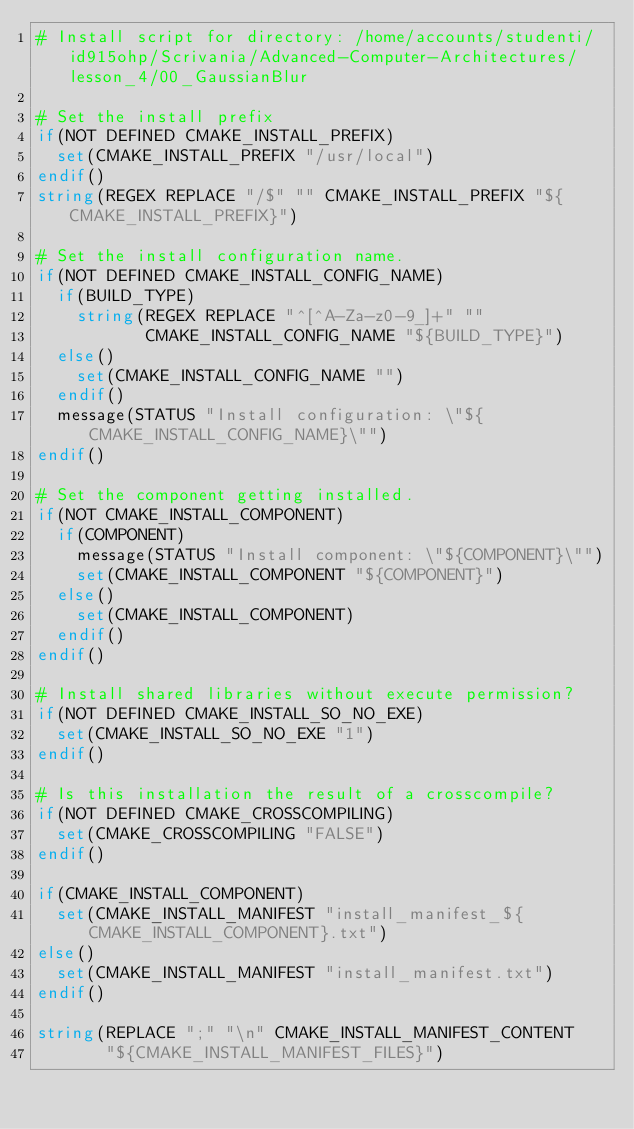Convert code to text. <code><loc_0><loc_0><loc_500><loc_500><_CMake_># Install script for directory: /home/accounts/studenti/id915ohp/Scrivania/Advanced-Computer-Architectures/lesson_4/00_GaussianBlur

# Set the install prefix
if(NOT DEFINED CMAKE_INSTALL_PREFIX)
  set(CMAKE_INSTALL_PREFIX "/usr/local")
endif()
string(REGEX REPLACE "/$" "" CMAKE_INSTALL_PREFIX "${CMAKE_INSTALL_PREFIX}")

# Set the install configuration name.
if(NOT DEFINED CMAKE_INSTALL_CONFIG_NAME)
  if(BUILD_TYPE)
    string(REGEX REPLACE "^[^A-Za-z0-9_]+" ""
           CMAKE_INSTALL_CONFIG_NAME "${BUILD_TYPE}")
  else()
    set(CMAKE_INSTALL_CONFIG_NAME "")
  endif()
  message(STATUS "Install configuration: \"${CMAKE_INSTALL_CONFIG_NAME}\"")
endif()

# Set the component getting installed.
if(NOT CMAKE_INSTALL_COMPONENT)
  if(COMPONENT)
    message(STATUS "Install component: \"${COMPONENT}\"")
    set(CMAKE_INSTALL_COMPONENT "${COMPONENT}")
  else()
    set(CMAKE_INSTALL_COMPONENT)
  endif()
endif()

# Install shared libraries without execute permission?
if(NOT DEFINED CMAKE_INSTALL_SO_NO_EXE)
  set(CMAKE_INSTALL_SO_NO_EXE "1")
endif()

# Is this installation the result of a crosscompile?
if(NOT DEFINED CMAKE_CROSSCOMPILING)
  set(CMAKE_CROSSCOMPILING "FALSE")
endif()

if(CMAKE_INSTALL_COMPONENT)
  set(CMAKE_INSTALL_MANIFEST "install_manifest_${CMAKE_INSTALL_COMPONENT}.txt")
else()
  set(CMAKE_INSTALL_MANIFEST "install_manifest.txt")
endif()

string(REPLACE ";" "\n" CMAKE_INSTALL_MANIFEST_CONTENT
       "${CMAKE_INSTALL_MANIFEST_FILES}")</code> 